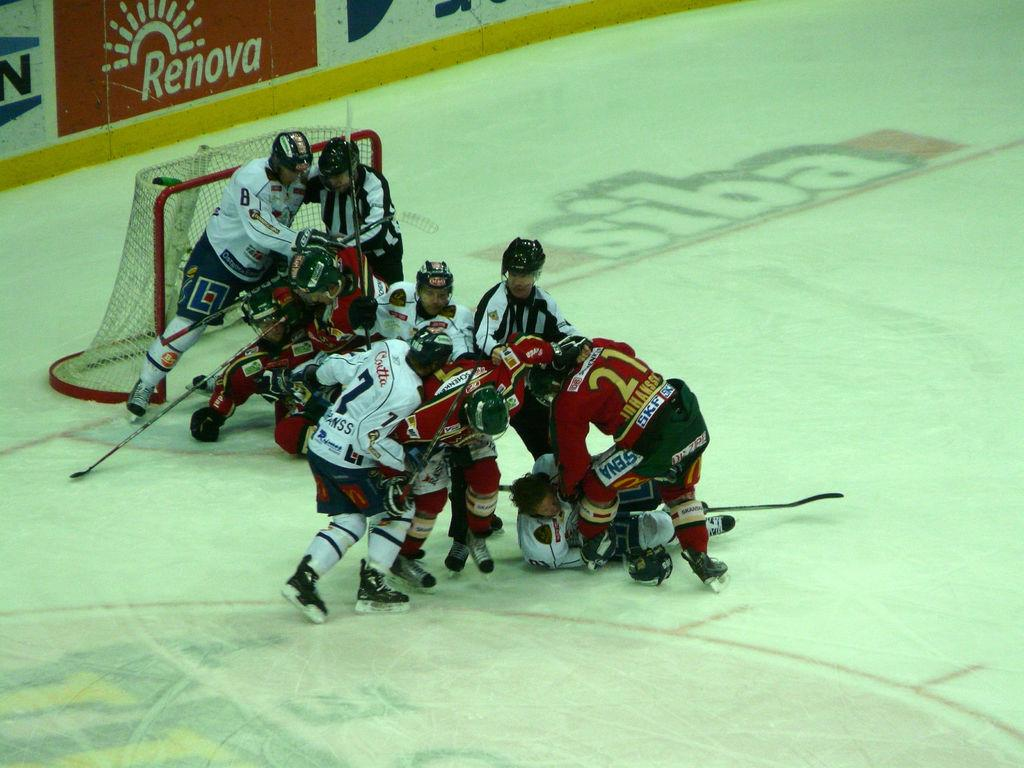What are the players in the image doing? The players in the image are on the ground, holding sticks. What type of footwear are the players wearing? The players are wearing skate shoes. What is the surface on which the players are standing? There is ice on the ground in the image. What is the objective of the game being played? There is a goal post in the image, suggesting that the players are playing a game where they need to score goals. What can be seen hanging or displayed in the image? There are banners in the image. What type of humor can be seen in the image? There is no humor present in the image; it depicts a game being played on ice. Can you tell me how many ants are crawling on the players' skate shoes in the image? There are no ants present in the image; the players are wearing skate shoes on ice. 